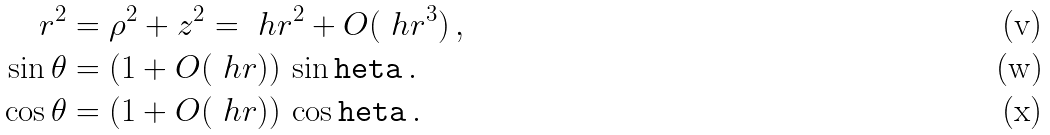Convert formula to latex. <formula><loc_0><loc_0><loc_500><loc_500>r ^ { 2 } & = \rho ^ { 2 } + z ^ { 2 } = \ h r ^ { 2 } + O ( \ h r ^ { 3 } ) \, , \\ \sin \theta & = ( 1 + O ( \ h r ) ) \, \sin \tt h e t a \, . \\ \cos \theta & = ( 1 + O ( \ h r ) ) \, \cos \tt h e t a \, .</formula> 